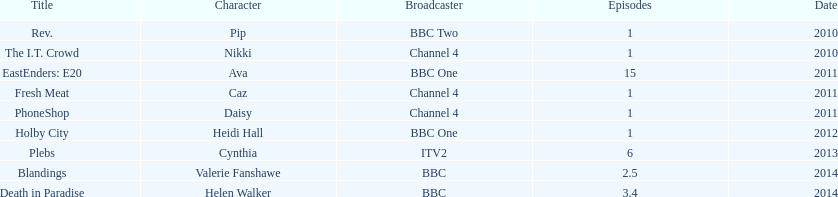Help me parse the entirety of this table. {'header': ['Title', 'Character', 'Broadcaster', 'Episodes', 'Date'], 'rows': [['Rev.', 'Pip', 'BBC Two', '1', '2010'], ['The I.T. Crowd', 'Nikki', 'Channel 4', '1', '2010'], ['EastEnders: E20', 'Ava', 'BBC One', '15', '2011'], ['Fresh Meat', 'Caz', 'Channel 4', '1', '2011'], ['PhoneShop', 'Daisy', 'Channel 4', '1', '2011'], ['Holby City', 'Heidi Hall', 'BBC One', '1', '2012'], ['Plebs', 'Cynthia', 'ITV2', '6', '2013'], ['Blandings', 'Valerie Fanshawe', 'BBC', '2.5', '2014'], ['Death in Paradise', 'Helen Walker', 'BBC', '3.4', '2014']]} What was the previous role this actress played before playing cynthia in plebs? Heidi Hall. 